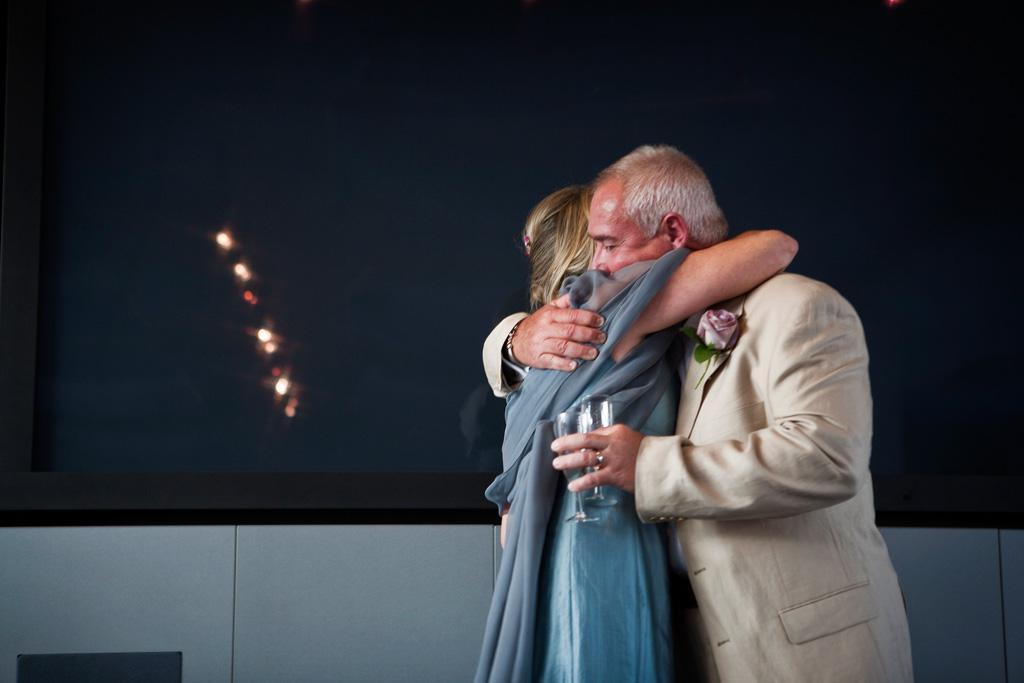What can be seen in the image? There is a flower, two people, and a man holding glasses in his hands. What is the man doing with the glasses? The man is holding glasses in his hands. What can be seen in the background of the image? There are lights, a wall, and some objects in the background of the image. What type of impulse can be seen affecting the guitar in the image? There is no guitar present in the image, so it is not possible to determine if any impulse is affecting it. 